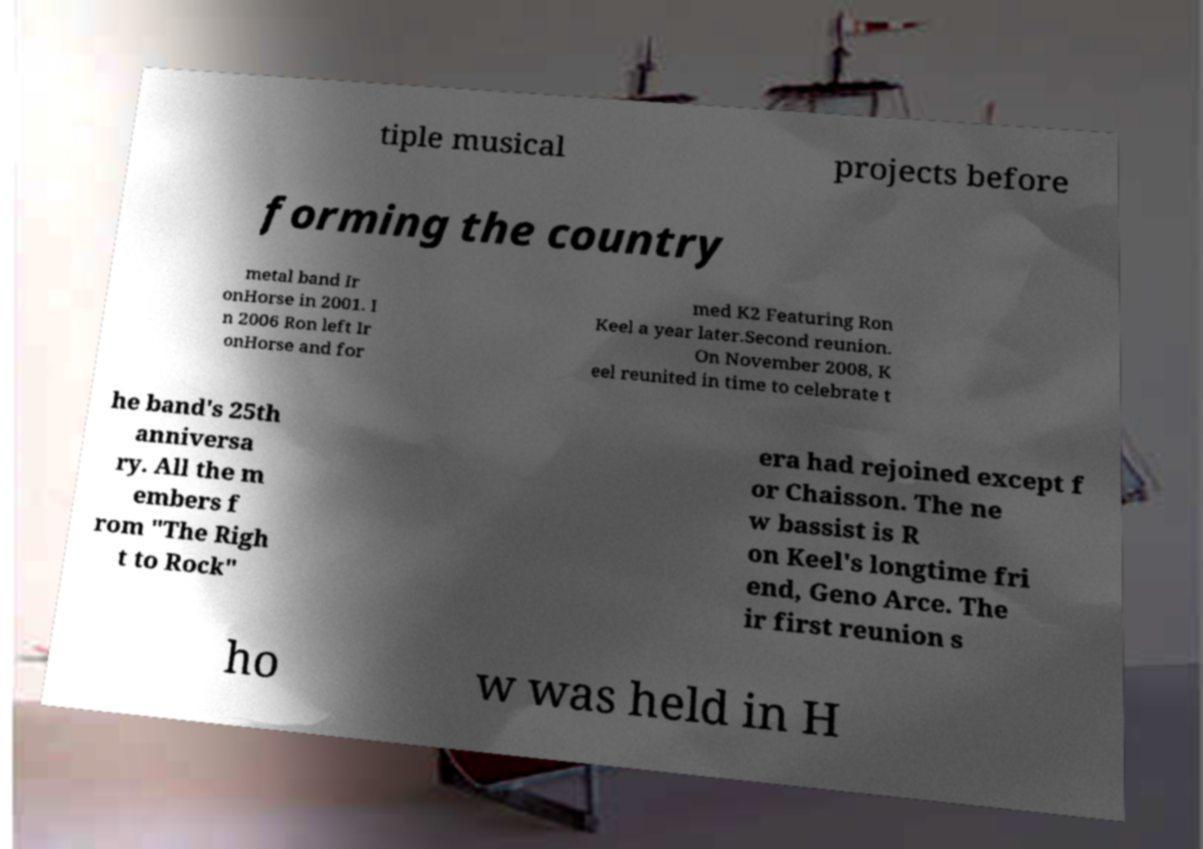Can you read and provide the text displayed in the image?This photo seems to have some interesting text. Can you extract and type it out for me? tiple musical projects before forming the country metal band Ir onHorse in 2001. I n 2006 Ron left Ir onHorse and for med K2 Featuring Ron Keel a year later.Second reunion. On November 2008, K eel reunited in time to celebrate t he band's 25th anniversa ry. All the m embers f rom "The Righ t to Rock" era had rejoined except f or Chaisson. The ne w bassist is R on Keel's longtime fri end, Geno Arce. The ir first reunion s ho w was held in H 